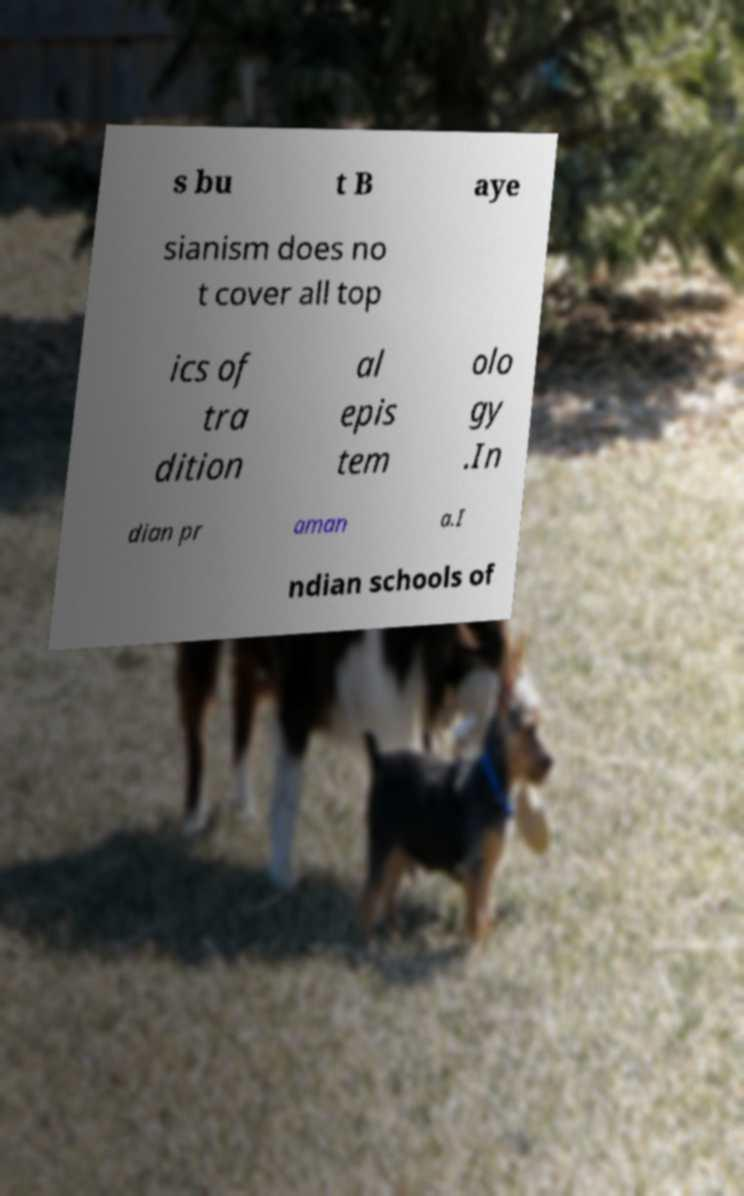Can you read and provide the text displayed in the image?This photo seems to have some interesting text. Can you extract and type it out for me? s bu t B aye sianism does no t cover all top ics of tra dition al epis tem olo gy .In dian pr aman a.I ndian schools of 